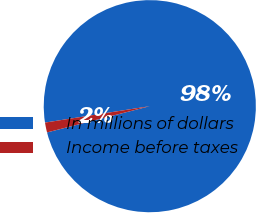Convert chart to OTSL. <chart><loc_0><loc_0><loc_500><loc_500><pie_chart><fcel>In millions of dollars<fcel>Income before taxes<nl><fcel>98.49%<fcel>1.51%<nl></chart> 